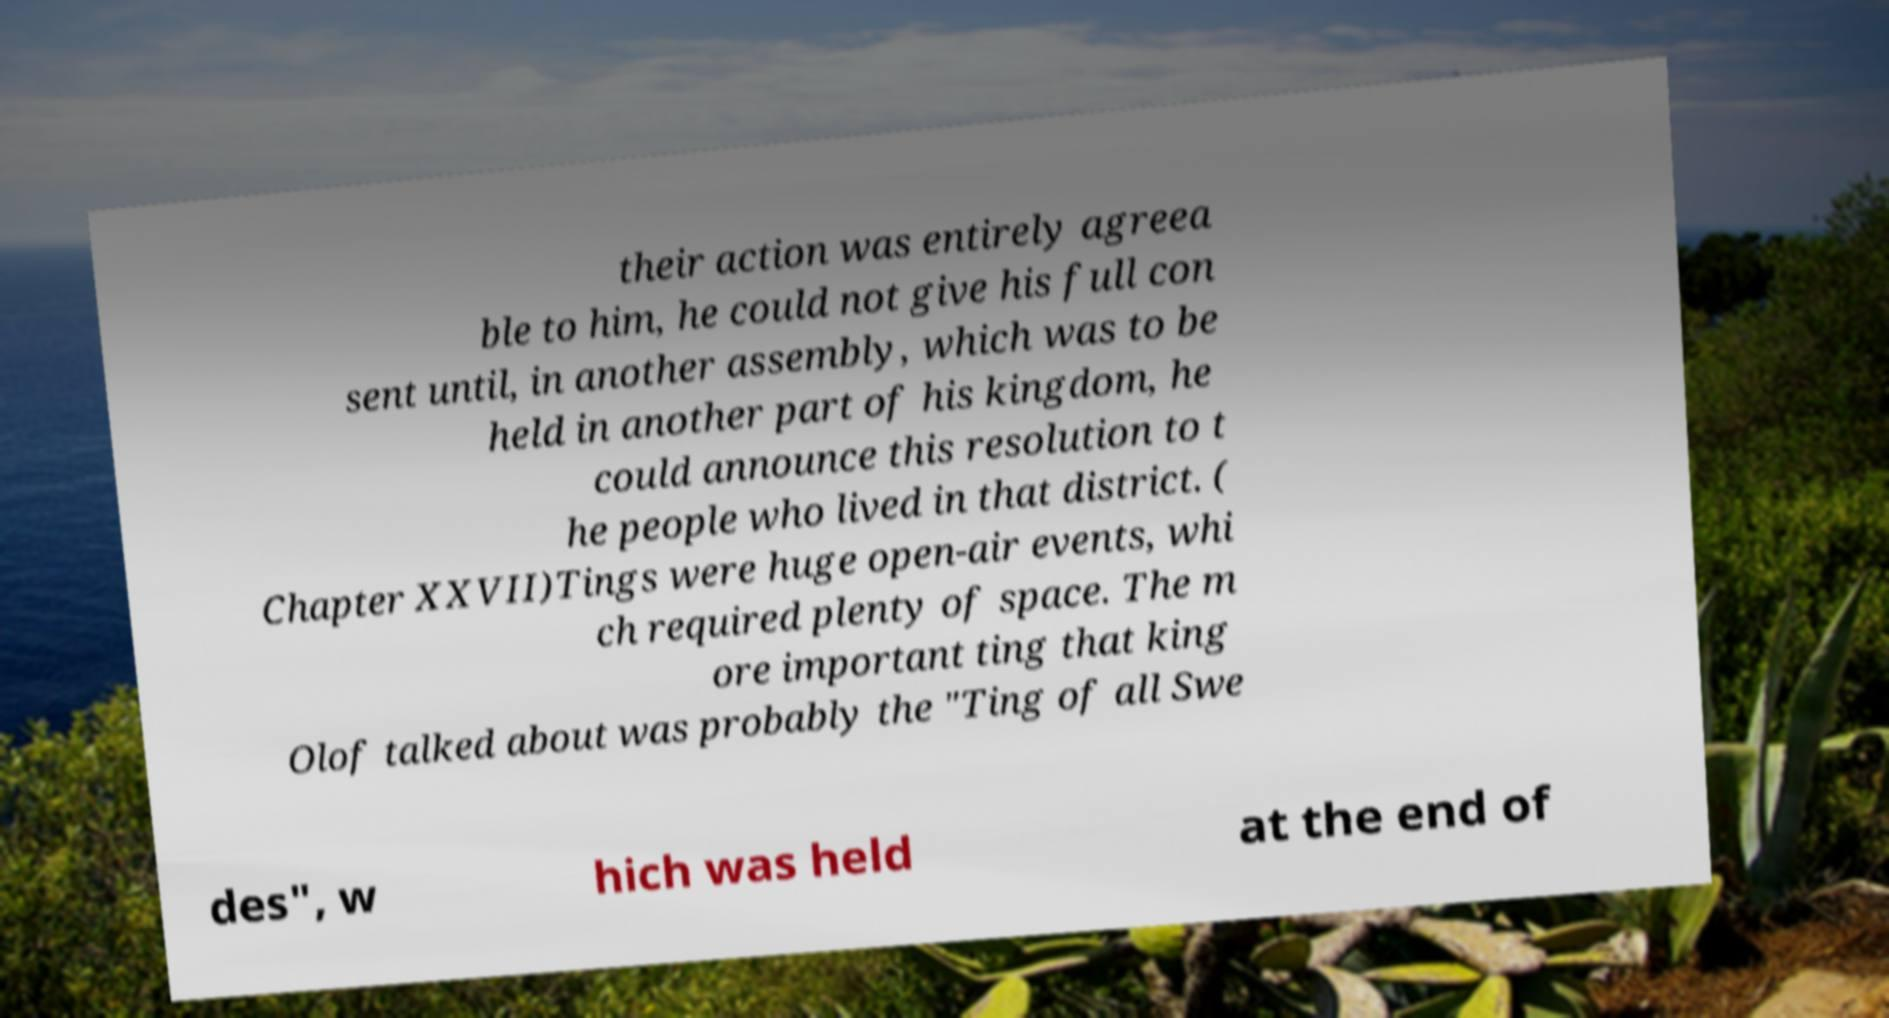Please read and relay the text visible in this image. What does it say? their action was entirely agreea ble to him, he could not give his full con sent until, in another assembly, which was to be held in another part of his kingdom, he could announce this resolution to t he people who lived in that district. ( Chapter XXVII)Tings were huge open-air events, whi ch required plenty of space. The m ore important ting that king Olof talked about was probably the "Ting of all Swe des", w hich was held at the end of 